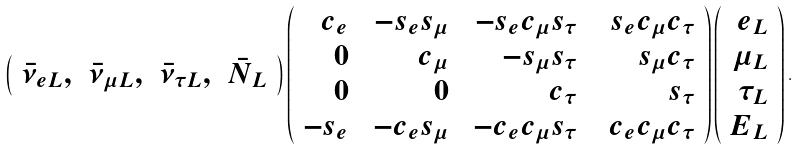<formula> <loc_0><loc_0><loc_500><loc_500>\left ( \begin{array} [ t ] { r r r r } \bar { \nu } _ { e L } , & \bar { \nu } _ { \mu L } , & \bar { \nu } _ { \tau L } , & \bar { N } _ { L } \end{array} \right ) \left ( \begin{array} { r r r r } c _ { e } \ & - s _ { e } s _ { \mu } \ & - s _ { e } c _ { \mu } s _ { \tau } \ \ & s _ { e } c _ { \mu } c _ { \tau } \\ 0 \ & c _ { \mu } \ & - s _ { \mu } s _ { \tau } \ \ & s _ { \mu } c _ { \tau } \\ 0 \ & 0 \ & c _ { \tau } \ \ & s _ { \tau } \\ - s _ { e } \ & - c _ { e } s _ { \mu } \ & - c _ { e } c _ { \mu } s _ { \tau } \ \ & c _ { e } c _ { \mu } c _ { \tau } \end{array} \right ) \left ( \begin{array} { r } e _ { L } \\ \mu _ { L } \\ \tau _ { L } \\ E _ { L } \end{array} \right ) .</formula> 